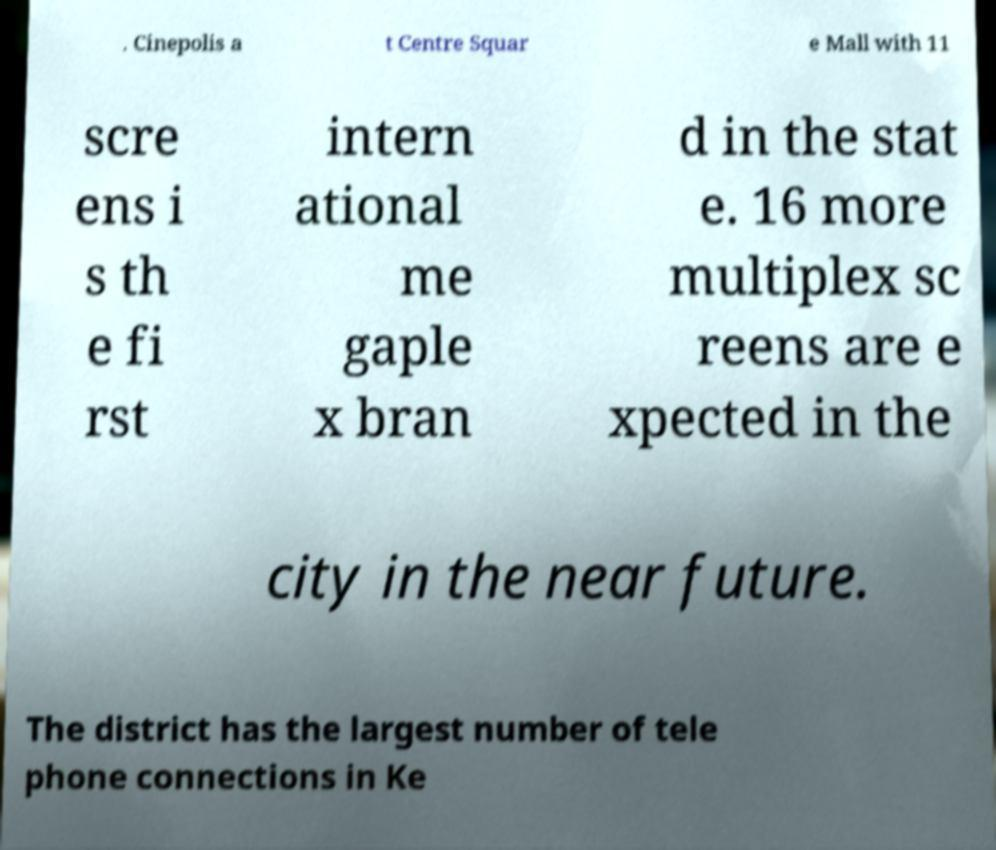Please read and relay the text visible in this image. What does it say? . Cinepolis a t Centre Squar e Mall with 11 scre ens i s th e fi rst intern ational me gaple x bran d in the stat e. 16 more multiplex sc reens are e xpected in the city in the near future. The district has the largest number of tele phone connections in Ke 